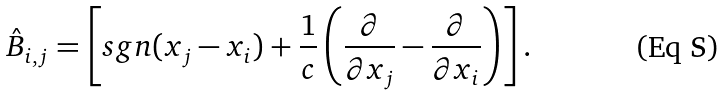<formula> <loc_0><loc_0><loc_500><loc_500>\hat { B } _ { i , j } = \left [ s g n ( x _ { j } - x _ { i } ) + \frac { 1 } { c } \left ( \frac { \partial } { \partial x _ { j } } - \frac { \partial } { \partial x _ { i } } \right ) \right ] .</formula> 